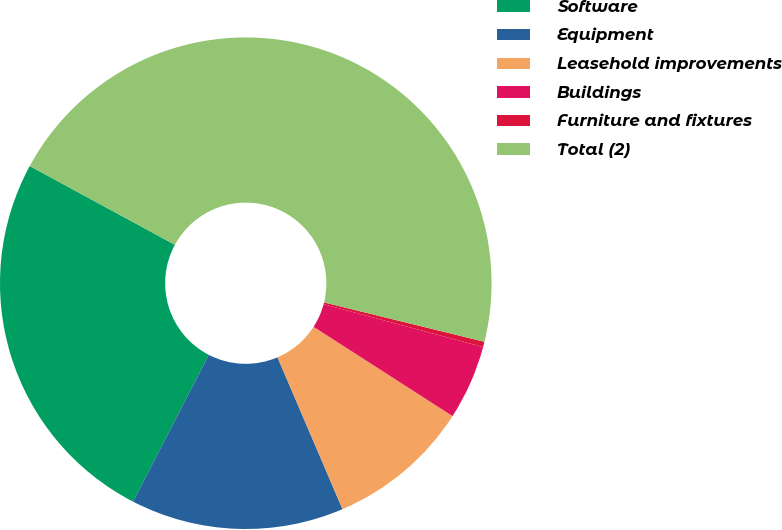Convert chart. <chart><loc_0><loc_0><loc_500><loc_500><pie_chart><fcel>Software<fcel>Equipment<fcel>Leasehold improvements<fcel>Buildings<fcel>Furniture and fixtures<fcel>Total (2)<nl><fcel>25.33%<fcel>14.02%<fcel>9.47%<fcel>4.91%<fcel>0.35%<fcel>45.92%<nl></chart> 